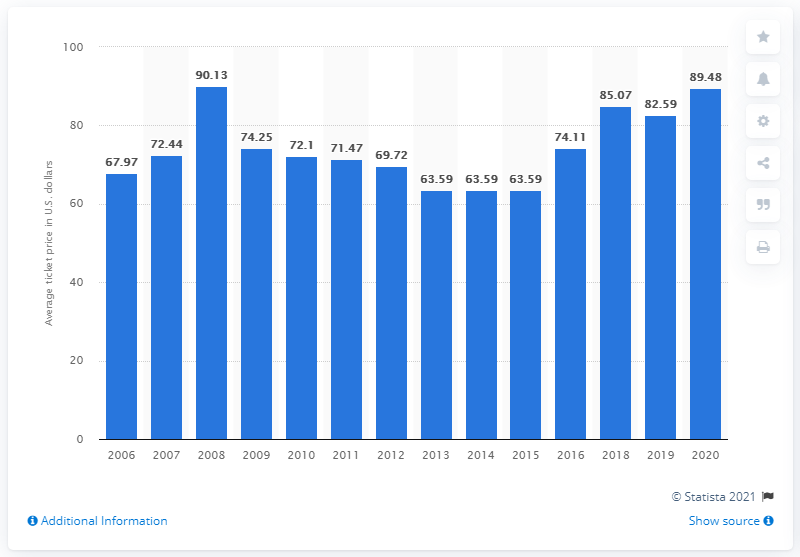List a handful of essential elements in this visual. The average ticket price for Tampa Bay Buccaneers games in 2020 was $89.48 per ticket. 